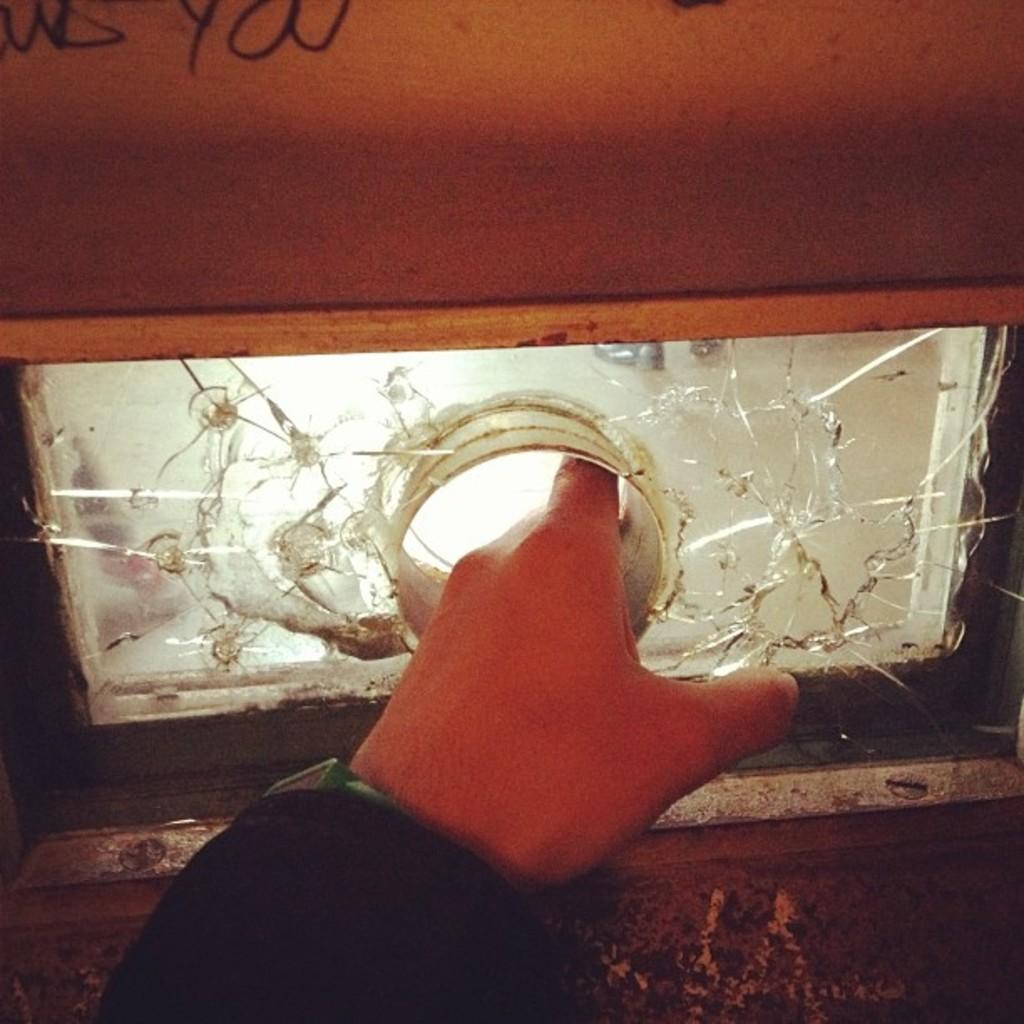What is the main feature of the wall in the image? The main feature of the wall in the image is the glass. Can you describe the glass on the wall? The glass has a hole in the center of the center. What type of sticks are used for learning in the image? There are no sticks or any learning materials present in the image. Why is the person in the image crying? There is no person present in the image, so it is not possible to determine if anyone is crying. 